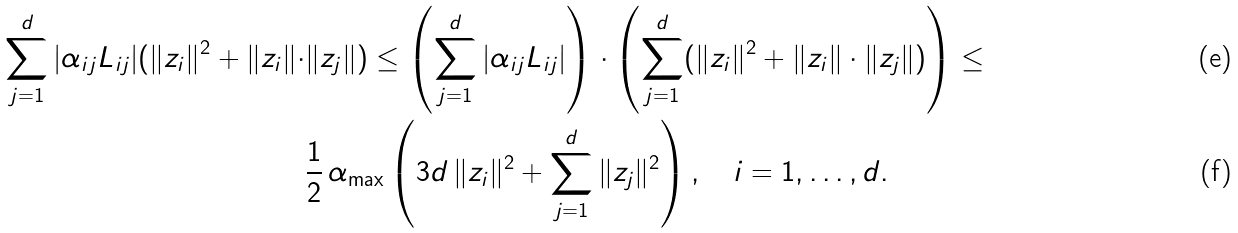<formula> <loc_0><loc_0><loc_500><loc_500>\sum _ { j = 1 } ^ { d } | \alpha _ { i j } L _ { i j } | ( \| z _ { i } \| ^ { 2 } + \| z _ { i } \| \cdot & \| z _ { j } \| ) \leq \left ( \sum _ { j = 1 } ^ { d } | \alpha _ { i j } L _ { i j } | \right ) \cdot \left ( \sum _ { j = 1 } ^ { d } ( \| z _ { i } \| ^ { 2 } + \| z _ { i } \| \cdot \| z _ { j } \| ) \right ) \leq \\ & \frac { 1 } { 2 } \, \alpha _ { \max } \left ( 3 d \, \| z _ { i } \| ^ { 2 } + \sum _ { j = 1 } ^ { d } \| z _ { j } \| ^ { 2 } \right ) , \quad i = 1 , \dots , d .</formula> 